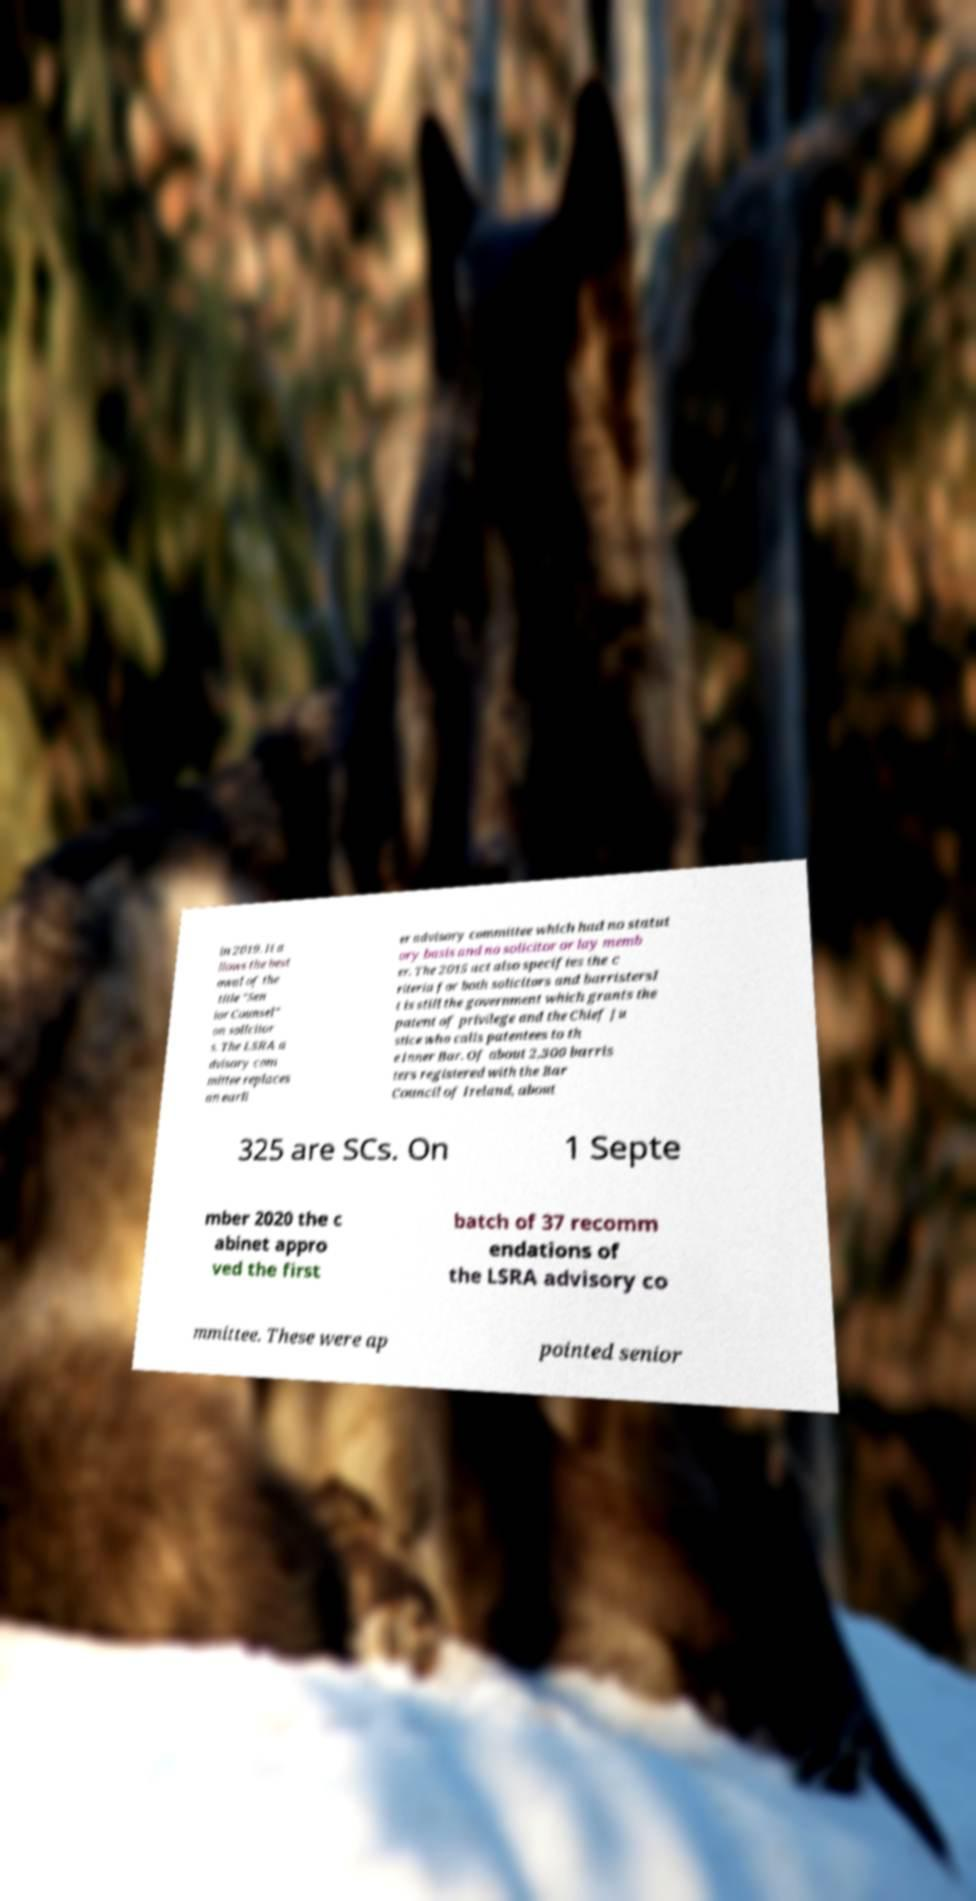For documentation purposes, I need the text within this image transcribed. Could you provide that? in 2019. It a llows the best owal of the title "Sen ior Counsel" on solicitor s. The LSRA a dvisory com mittee replaces an earli er advisory committee which had no statut ory basis and no solicitor or lay memb er. The 2015 act also specifies the c riteria for both solicitors and barristersI t is still the government which grants the patent of privilege and the Chief Ju stice who calls patentees to th e Inner Bar. Of about 2,300 barris ters registered with the Bar Council of Ireland, about 325 are SCs. On 1 Septe mber 2020 the c abinet appro ved the first batch of 37 recomm endations of the LSRA advisory co mmittee. These were ap pointed senior 